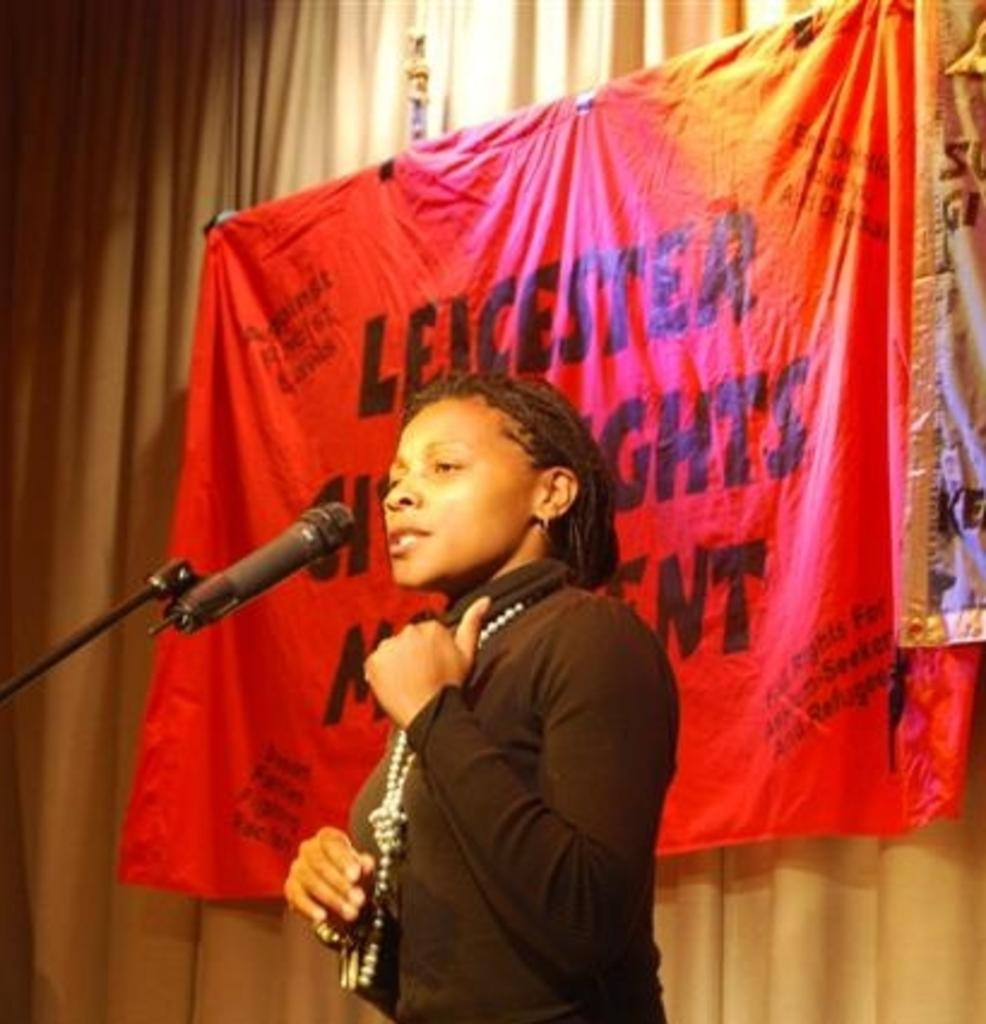Who is the main subject in the image? There is a lady in the image. What is the lady wearing in the image? The lady is wearing a necklace in the image. What is the lady's posture in the image? The lady is standing in the image. What is in front of the lady in the image? There is a mic and a mic stand in front of the lady in the image. What can be seen in the background of the image? There are curtains and a banner in the background of the image. What type of iron is being used to press the lady's clothes in the image? There is no iron present in the image; the lady is wearing a necklace and standing in front of a mic and a mic stand. 